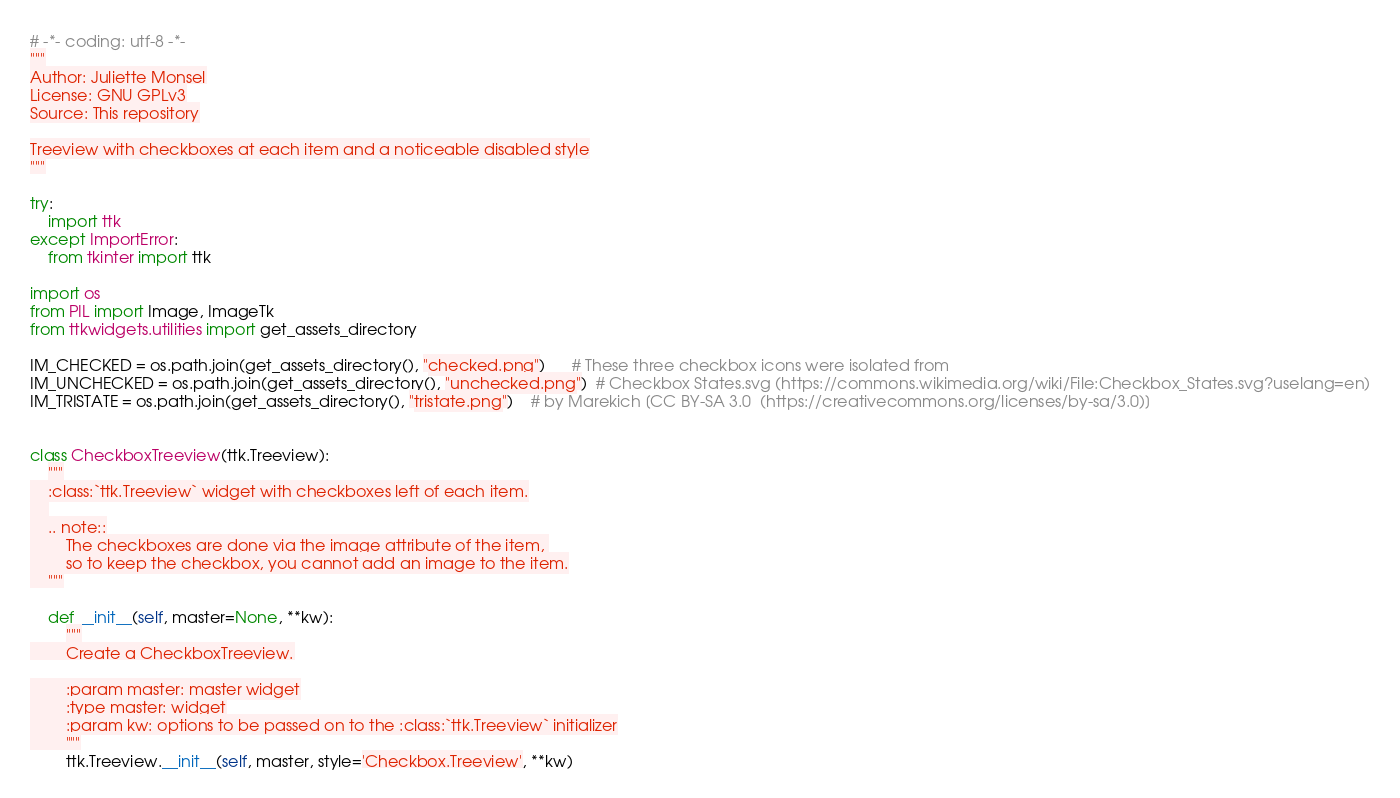<code> <loc_0><loc_0><loc_500><loc_500><_Python_># -*- coding: utf-8 -*-
"""
Author: Juliette Monsel
License: GNU GPLv3
Source: This repository

Treeview with checkboxes at each item and a noticeable disabled style
"""

try:
    import ttk
except ImportError:
    from tkinter import ttk

import os
from PIL import Image, ImageTk
from ttkwidgets.utilities import get_assets_directory

IM_CHECKED = os.path.join(get_assets_directory(), "checked.png")      # These three checkbox icons were isolated from
IM_UNCHECKED = os.path.join(get_assets_directory(), "unchecked.png")  # Checkbox States.svg (https://commons.wikimedia.org/wiki/File:Checkbox_States.svg?uselang=en)
IM_TRISTATE = os.path.join(get_assets_directory(), "tristate.png")    # by Marekich [CC BY-SA 3.0  (https://creativecommons.org/licenses/by-sa/3.0)]


class CheckboxTreeview(ttk.Treeview):
    """
    :class:`ttk.Treeview` widget with checkboxes left of each item.
    
    .. note::
        The checkboxes are done via the image attribute of the item, 
        so to keep the checkbox, you cannot add an image to the item.
    """

    def __init__(self, master=None, **kw):
        """
        Create a CheckboxTreeview.

        :param master: master widget
        :type master: widget
        :param kw: options to be passed on to the :class:`ttk.Treeview` initializer
        """
        ttk.Treeview.__init__(self, master, style='Checkbox.Treeview', **kw)</code> 